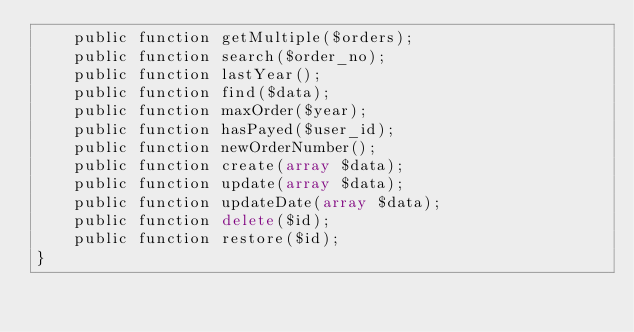Convert code to text. <code><loc_0><loc_0><loc_500><loc_500><_PHP_>    public function getMultiple($orders);
    public function search($order_no);
    public function lastYear();
	public function find($data);
    public function maxOrder($year);
    public function hasPayed($user_id);
    public function newOrderNumber();
	public function create(array $data);
	public function update(array $data);
    public function updateDate(array $data);
	public function delete($id);
    public function restore($id);
}
</code> 